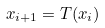<formula> <loc_0><loc_0><loc_500><loc_500>x _ { i + 1 } = T ( x _ { i } )</formula> 